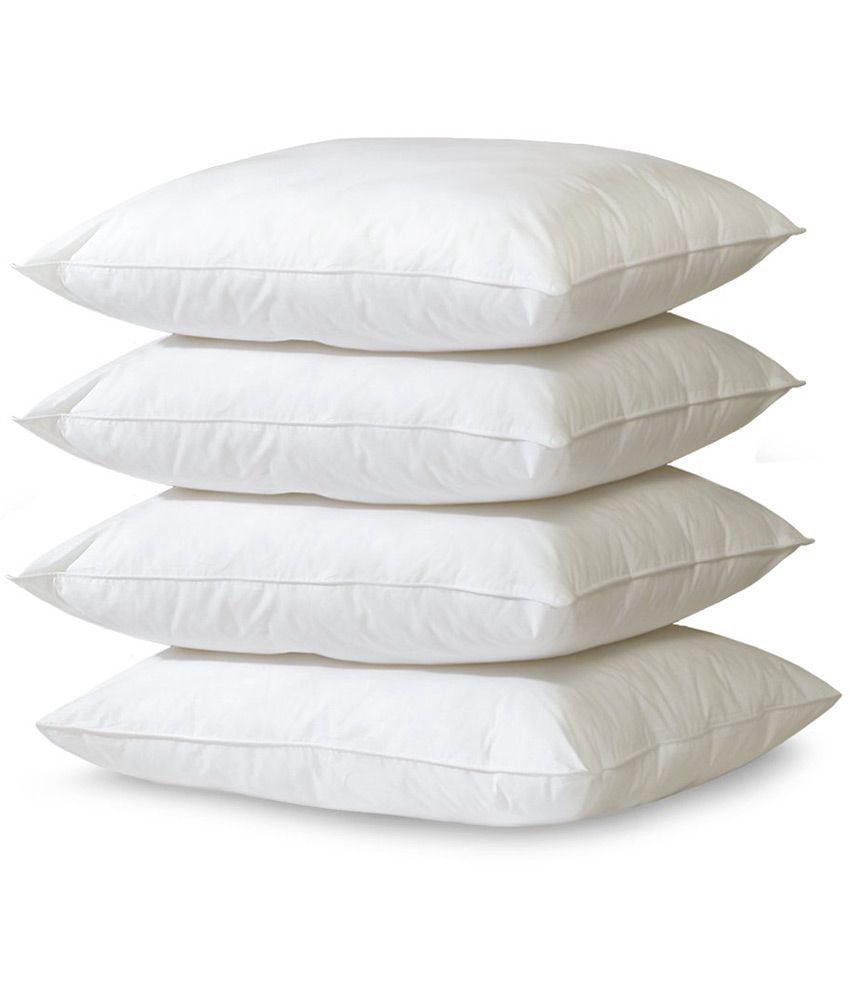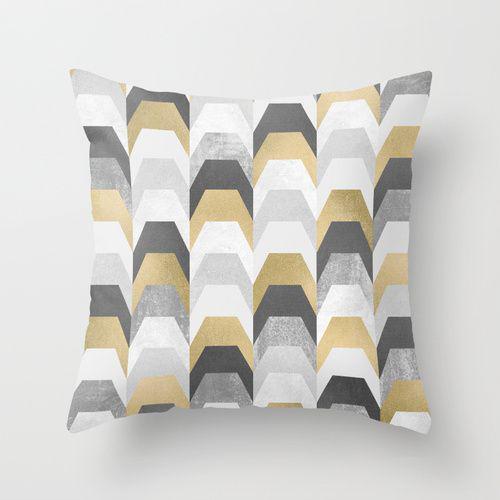The first image is the image on the left, the second image is the image on the right. Considering the images on both sides, is "multiple pillows are stacked on top of each other" valid? Answer yes or no. Yes. 